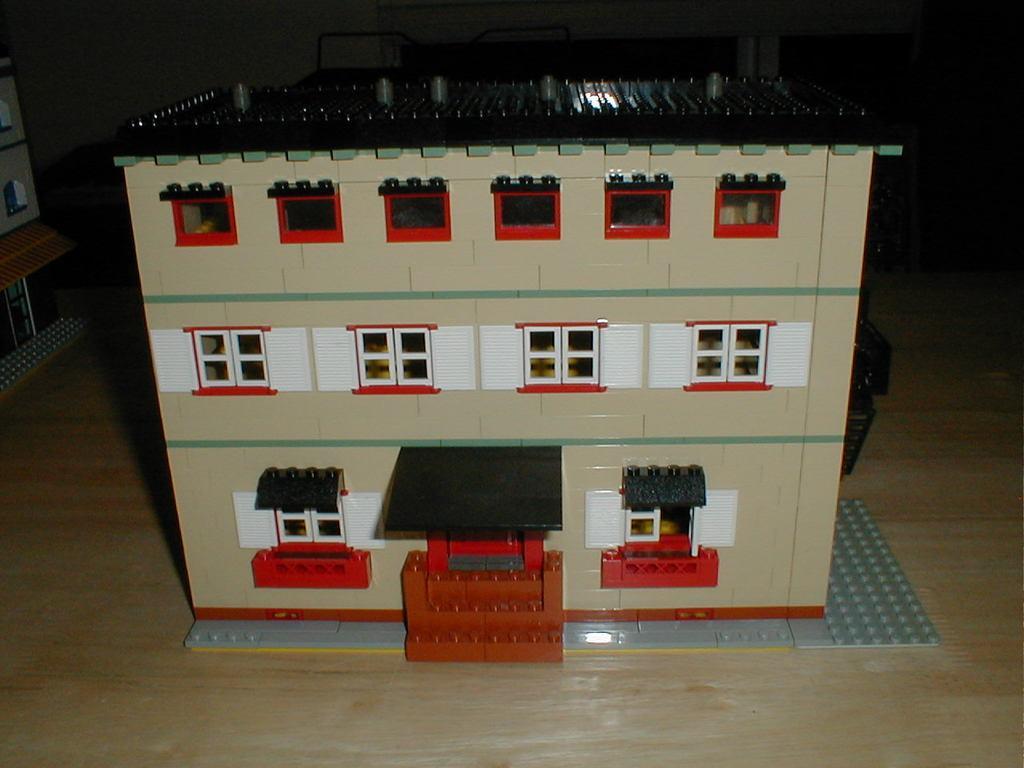How would you summarize this image in a sentence or two? In this image we can see a house with windows on it. Which is built by Lego blocks placed on the floor. In the background we can see another building. 